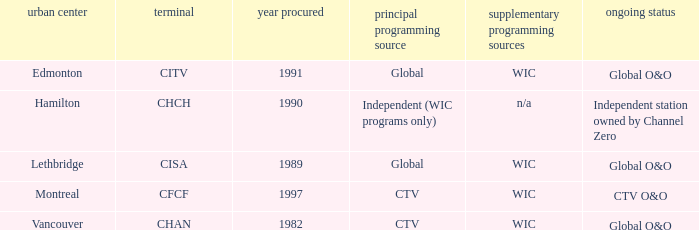How many is the minimum for citv 1991.0. 